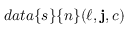<formula> <loc_0><loc_0><loc_500><loc_500>d a t a \{ s \} \{ n \} ( \ell , j , c )</formula> 